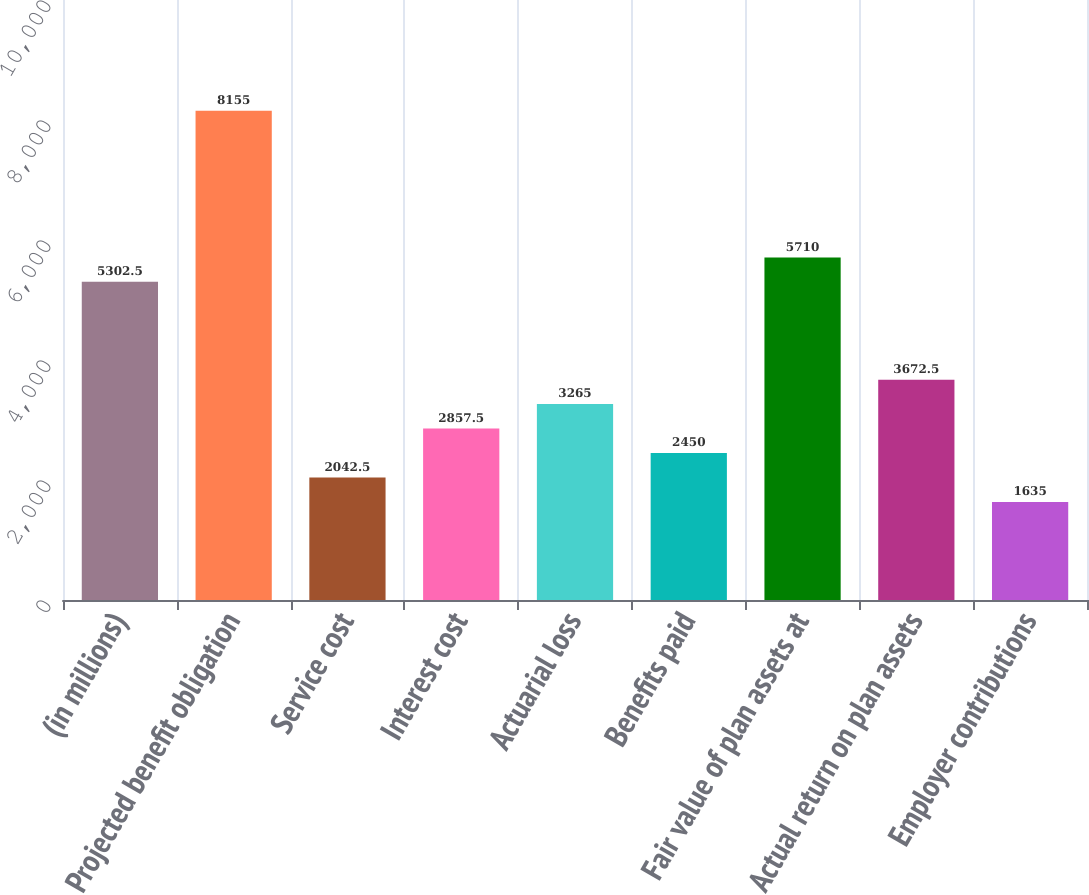<chart> <loc_0><loc_0><loc_500><loc_500><bar_chart><fcel>(in millions)<fcel>Projected benefit obligation<fcel>Service cost<fcel>Interest cost<fcel>Actuarial loss<fcel>Benefits paid<fcel>Fair value of plan assets at<fcel>Actual return on plan assets<fcel>Employer contributions<nl><fcel>5302.5<fcel>8155<fcel>2042.5<fcel>2857.5<fcel>3265<fcel>2450<fcel>5710<fcel>3672.5<fcel>1635<nl></chart> 